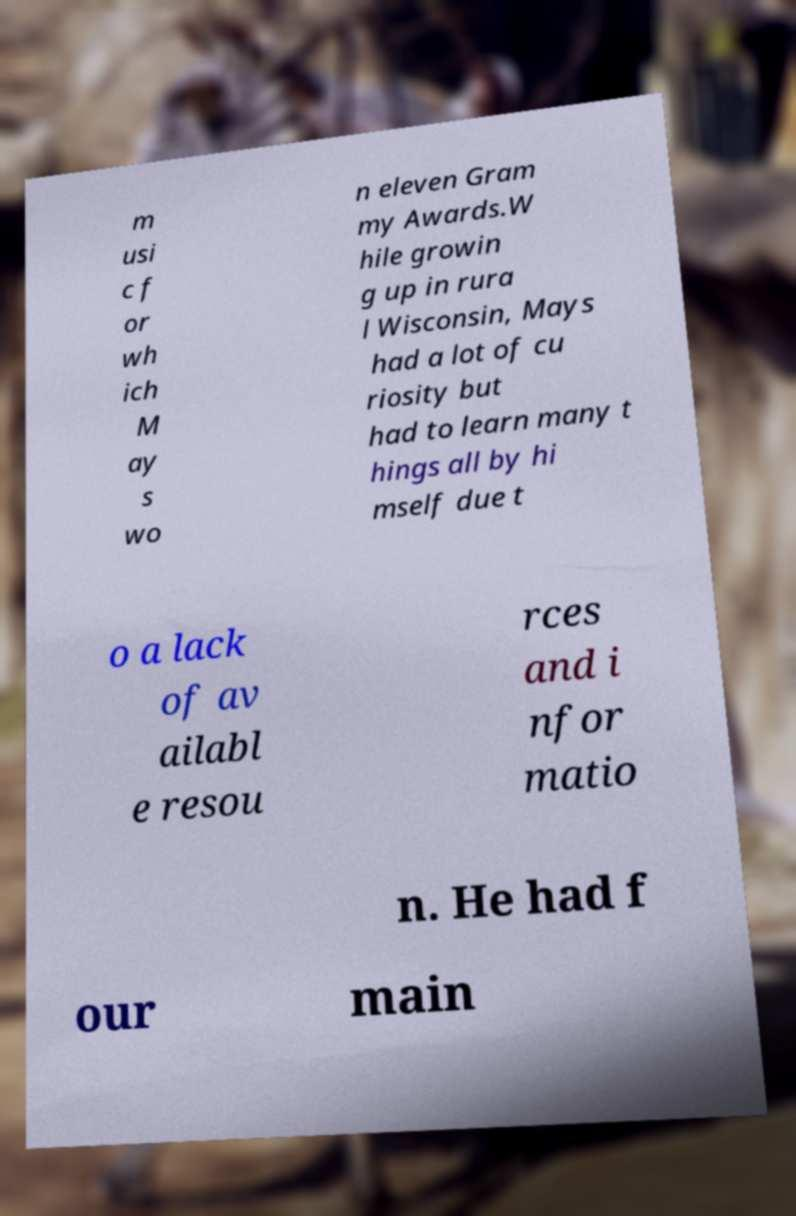Can you read and provide the text displayed in the image?This photo seems to have some interesting text. Can you extract and type it out for me? m usi c f or wh ich M ay s wo n eleven Gram my Awards.W hile growin g up in rura l Wisconsin, Mays had a lot of cu riosity but had to learn many t hings all by hi mself due t o a lack of av ailabl e resou rces and i nfor matio n. He had f our main 